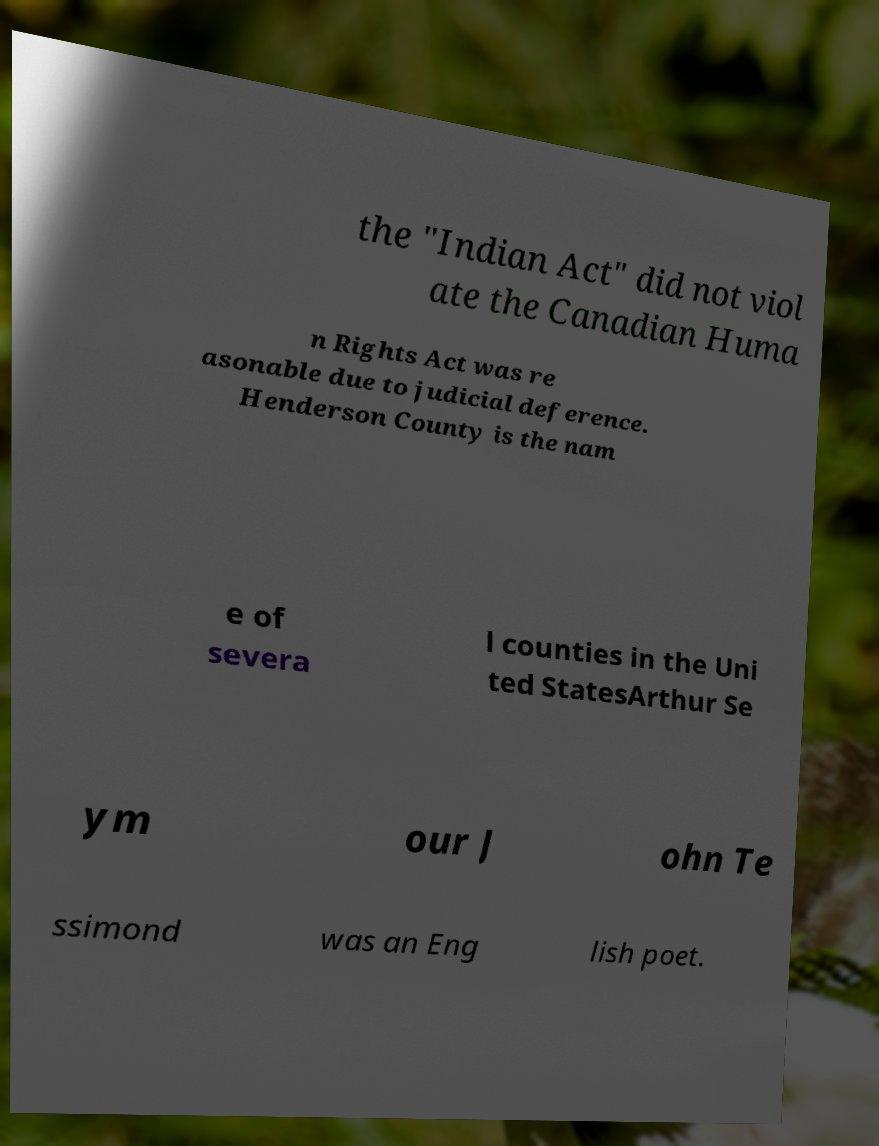Could you assist in decoding the text presented in this image and type it out clearly? the "Indian Act" did not viol ate the Canadian Huma n Rights Act was re asonable due to judicial deference. Henderson County is the nam e of severa l counties in the Uni ted StatesArthur Se ym our J ohn Te ssimond was an Eng lish poet. 